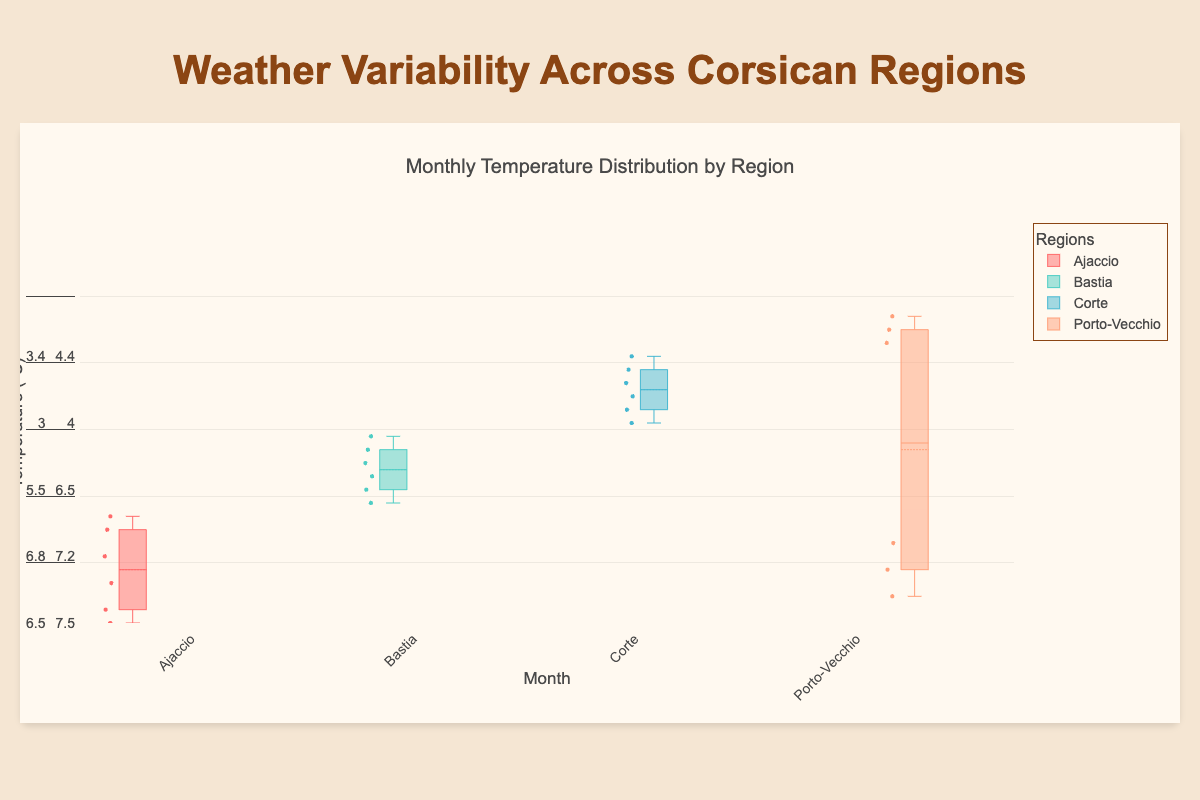Which region shows the highest median temperature in August? The box plot's median line represents the median temperature. In August, check all the box plots and identify the one with the highest median line.
Answer: Porto-Vecchio What is the approximate range of temperatures for Ajaccio in January? The range is calculated by subtracting the lower whisker value from the upper whisker value. For Ajaccio in January, check the temperature values at the top and bottom whiskers of the box plot.
Answer: About 6.5°C to 7.2°C Which region has the smallest interquartile range (IQR) in February? The IQR is the difference between the upper quartile (Q3) and lower quartile (Q1). For February, compare the heights of the box in each region and identify the smallest one.
Answer: Corte In what region and month is the temperature range (maximum minus minimum) the largest? Find the box plot with the greatest distance between the top and bottom whiskers, indicating a large temperature range.
Answer: Porto-Vecchio in August How does the median temperature in March compare between Ajaccio and Bastia? Compare the median lines (middle lines within the boxes) for March between Ajaccio and Bastia. Observe which one is higher or lower.
Answer: Ajaccio's median is higher than Bastia's Which region has the highest maximum temperature recorded in the year? Look for the highest point on the entire plot, which represents the maximum temperature recorded. Identify the corresponding region.
Answer: Porto-Vecchio What is the difference between the median temperatures of Corte in April and December? Locate the median lines for Corte in both April and December and compute their difference.
Answer: 9°C in April - 4°C in December = 5°C Does any region show the same median temperature in multiple months? Compare the median lines across all months for each region. Check for any horizontal alignment indicating the same value.
Answer: No Which month has the most consistent temperatures across all regions? Assess the length of the boxes (representing IQR) across all regions for each month. The month with the shortest boxes overall is the most consistent.
Answer: October Which region shows the widest variability in temperatures throughout the year? Evaluate the spread of whiskers and the height of the boxes for each region across all months. The region with the widest spread indicates the most variability.
Answer: Porto-Vecchio 